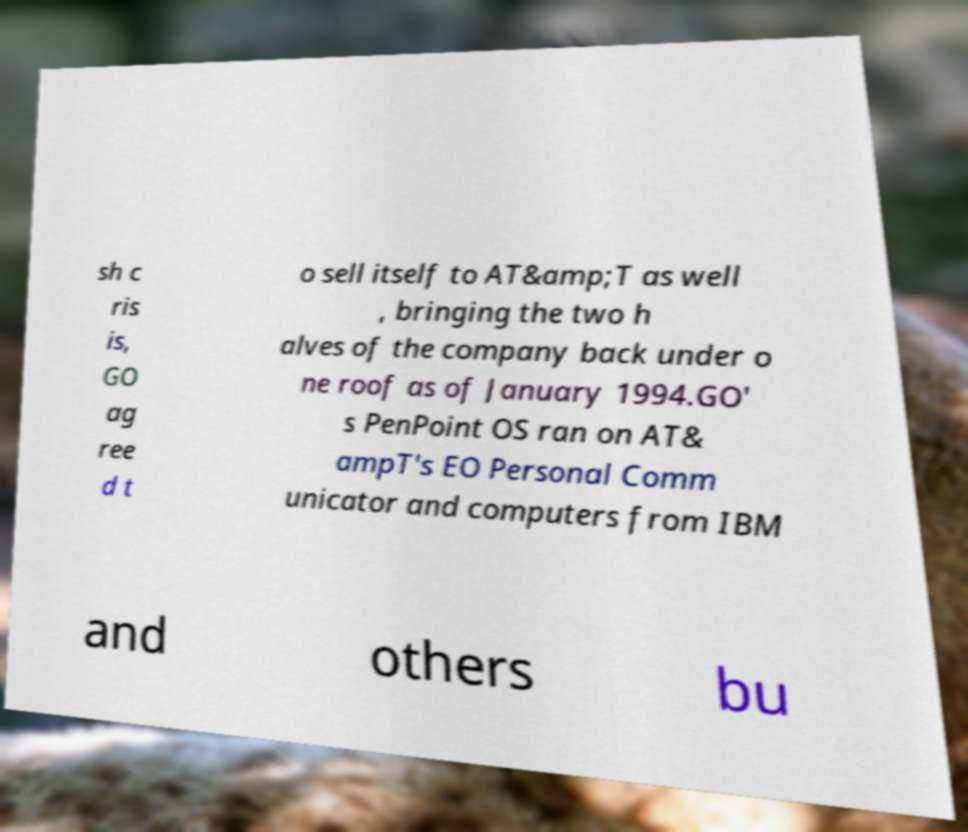Please read and relay the text visible in this image. What does it say? sh c ris is, GO ag ree d t o sell itself to AT&amp;T as well , bringing the two h alves of the company back under o ne roof as of January 1994.GO' s PenPoint OS ran on AT& ampT's EO Personal Comm unicator and computers from IBM and others bu 